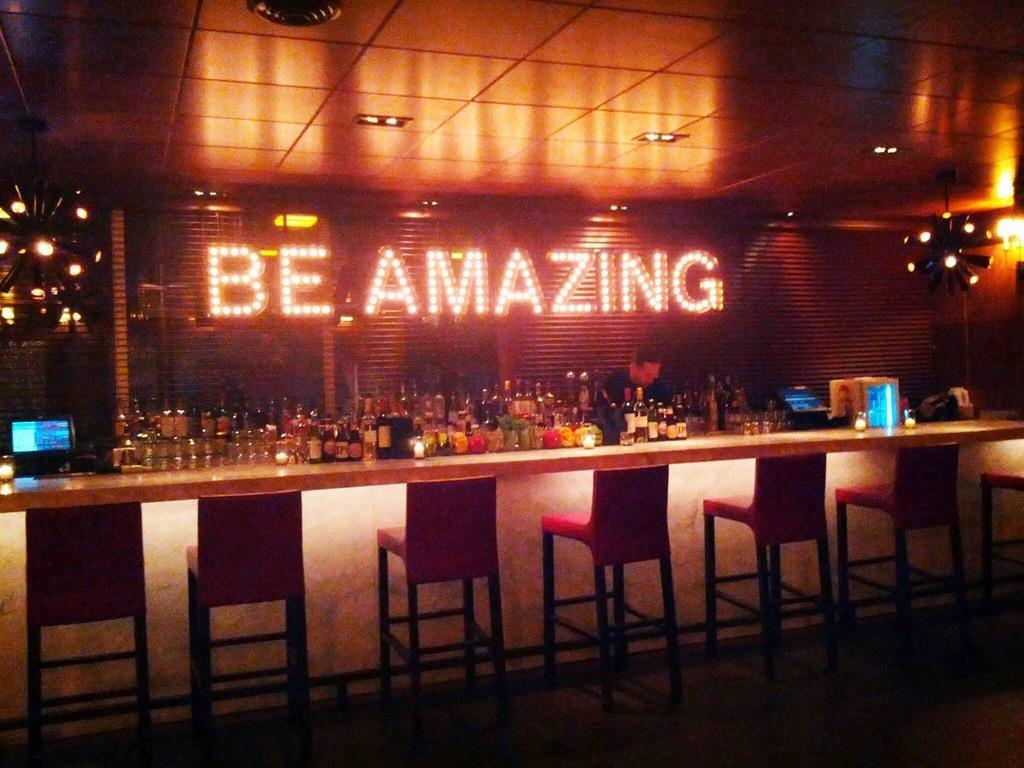Please provide a concise description of this image. In this image I can see there are chairs. In the middle there are wine bottles, here be amazing with lights. 